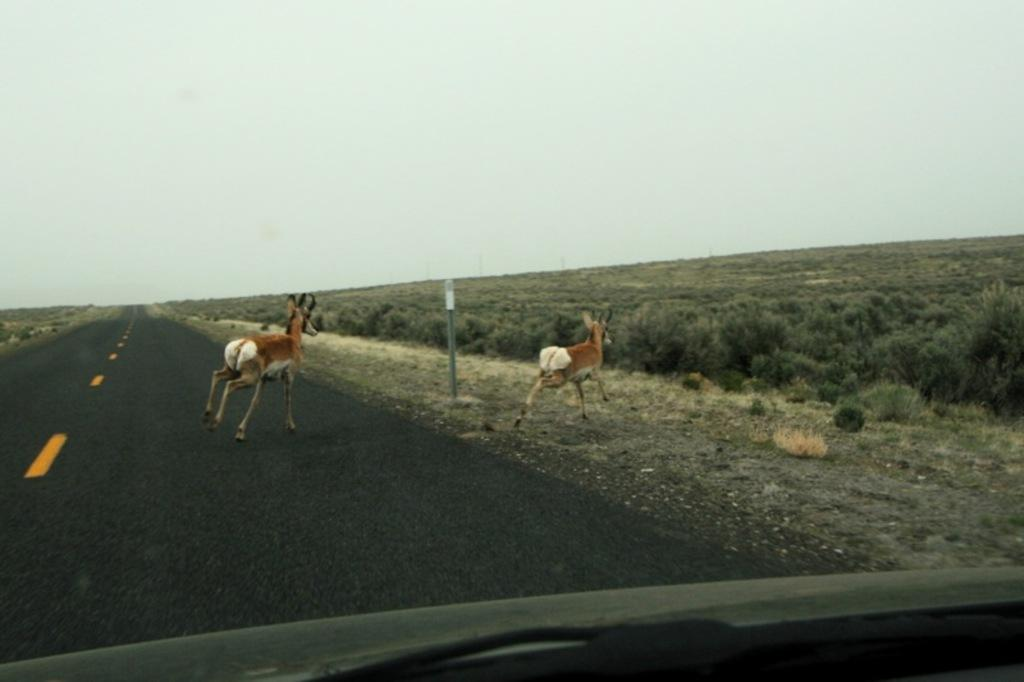What types of living organisms can be seen in the image? There are animals in the image. What can be seen beneath the animals and plants? The ground is visible in the image. What type of vegetation is present in the image? There is grass and plants in the image. What is the object in the image? The object in the image is not specified, but it is mentioned that it exists. What is visible in the background of the image? The sky is visible in the image. What architectural feature can be seen in the image? There is a pole in the image. How many women are present in the image? There is no mention of women in the image, so it cannot be determined how many are present. What type of coil is being used by the animals in the image? There is no coil present in the image, so it cannot be determined what type it might be or how it is being used. 